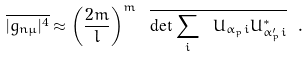<formula> <loc_0><loc_0><loc_500><loc_500>\overline { | g _ { n \mu } | ^ { 4 } } \approx \left ( \frac { 2 m } { l } \right ) ^ { m } \ \overline { \det \sum _ { i } \ U _ { \alpha _ { p } i } U ^ { * } _ { \alpha ^ { \prime } _ { p } i } } \ .</formula> 